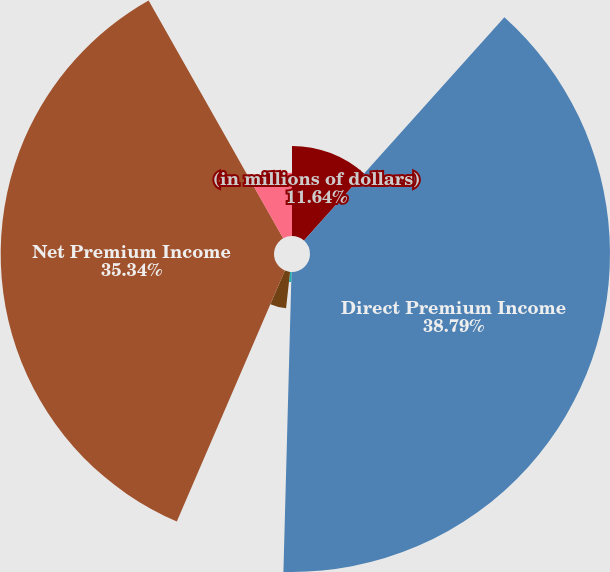Convert chart. <chart><loc_0><loc_0><loc_500><loc_500><pie_chart><fcel>(in millions of dollars)<fcel>Direct Premium Income<fcel>Reinsurance Assumed<fcel>Reinsurance Ceded<fcel>Net Premium Income<fcel>Ceded Benefits and Change in<nl><fcel>11.64%<fcel>38.79%<fcel>1.3%<fcel>4.74%<fcel>35.34%<fcel>8.19%<nl></chart> 